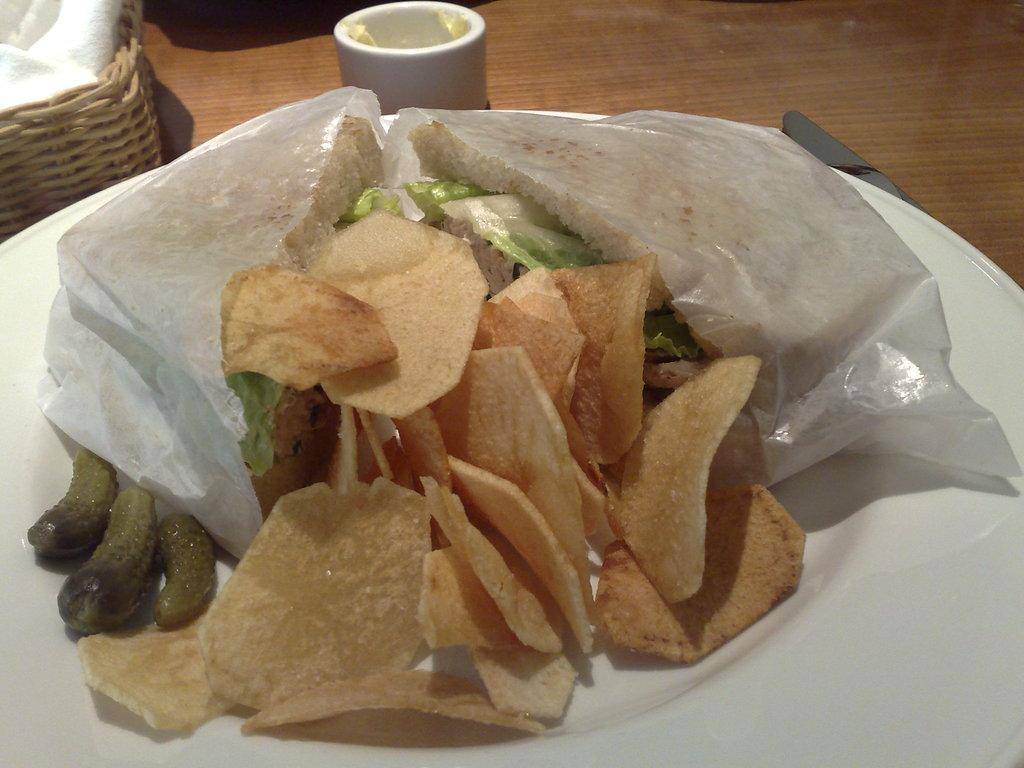What piece of furniture is present in the image? There is a table in the image. What is on the table? There is a cup of butter, a basket with a cloth, and a plate with chips, cucumbers, and a sandwich on the table. How many cows are visible in the image? There are no cows present in the image. What type of line is used to decorate the plate in the image? There is no line decoration on the plate in the image. 